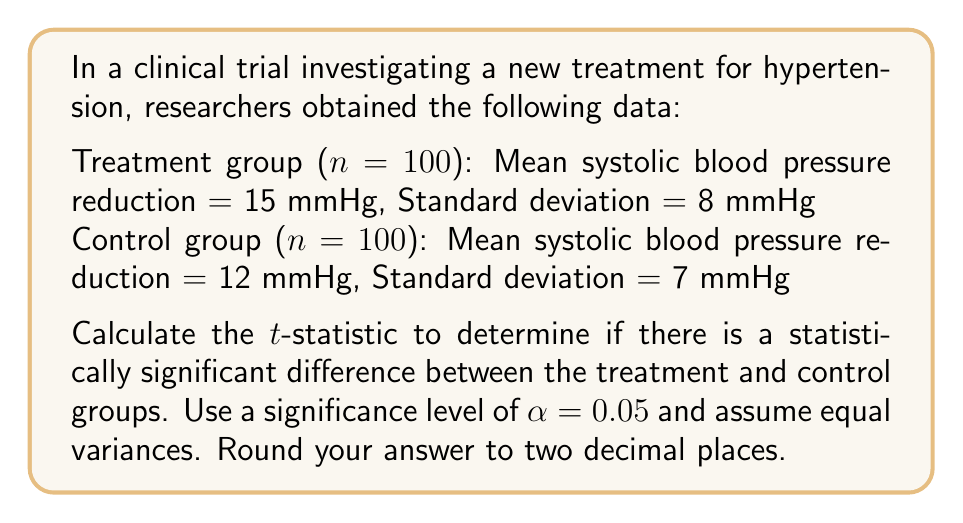Can you solve this math problem? To determine if there is a statistically significant difference between the treatment and control groups, we need to calculate the t-statistic and compare it to the critical value.

Step 1: Calculate the pooled standard deviation
The formula for pooled standard deviation is:

$$ s_p = \sqrt{\frac{(n_1 - 1)s_1^2 + (n_2 - 1)s_2^2}{n_1 + n_2 - 2}} $$

Where:
$n_1 = n_2 = 100$ (sample sizes)
$s_1 = 8$ (standard deviation of treatment group)
$s_2 = 7$ (standard deviation of control group)

$$ s_p = \sqrt{\frac{(100 - 1)8^2 + (100 - 1)7^2}{100 + 100 - 2}} = \sqrt{\frac{6328 + 4851}{198}} = \sqrt{56.46} = 7.51 $$

Step 2: Calculate the t-statistic
The formula for the t-statistic is:

$$ t = \frac{\bar{x}_1 - \bar{x}_2}{s_p\sqrt{\frac{2}{n}}} $$

Where:
$\bar{x}_1 = 15$ (mean of treatment group)
$\bar{x}_2 = 12$ (mean of control group)
$n = 100$ (sample size per group)

$$ t = \frac{15 - 12}{7.51\sqrt{\frac{2}{100}}} = \frac{3}{7.51 \times 0.1414} = \frac{3}{1.06} = 2.83 $$

Step 3: Determine the critical value
For a two-tailed test with α = 0.05 and degrees of freedom = n1 + n2 - 2 = 198, the critical value is approximately ±1.97 (from t-distribution tables).

Step 4: Compare the t-statistic to the critical value
Since |2.83| > 1.97, we reject the null hypothesis and conclude that there is a statistically significant difference between the treatment and control groups.
Answer: $t = 2.83$ 